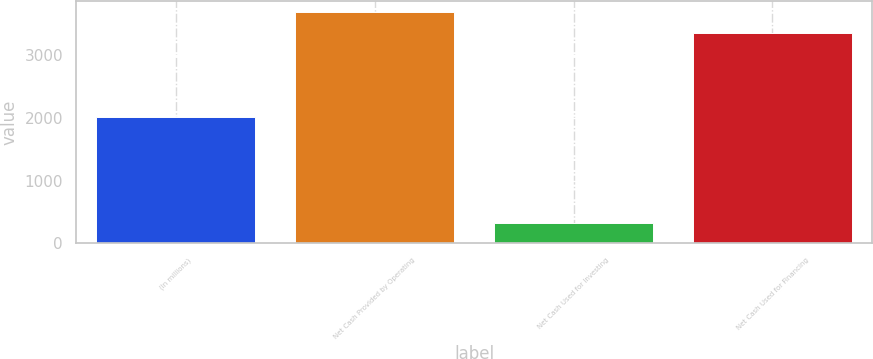<chart> <loc_0><loc_0><loc_500><loc_500><bar_chart><fcel>(In millions)<fcel>Net Cash Provided by Operating<fcel>Net Cash Used for Investing<fcel>Net Cash Used for Financing<nl><fcel>2010<fcel>3685.8<fcel>319<fcel>3363<nl></chart> 